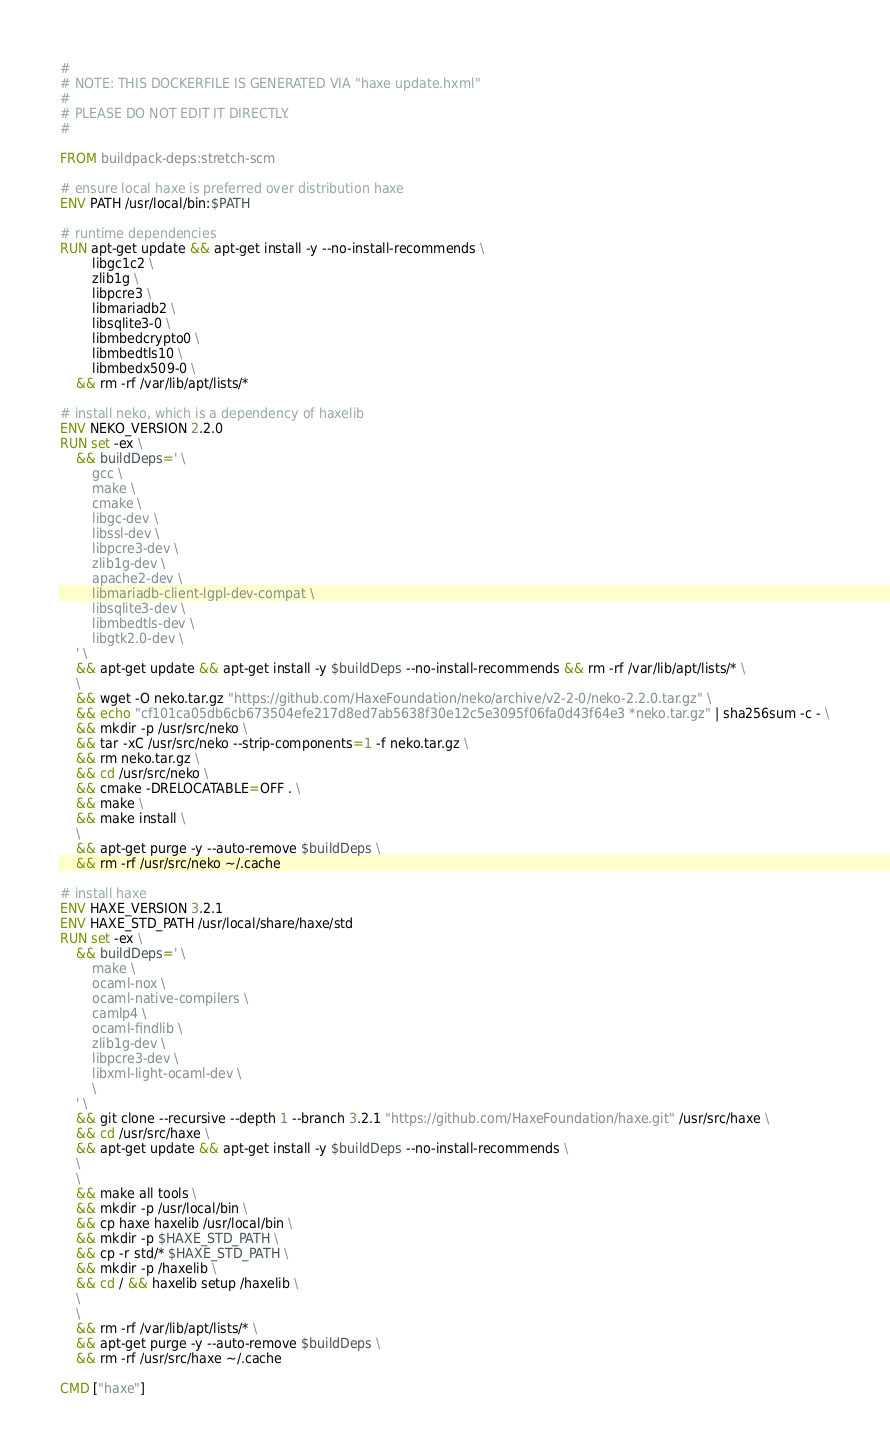Convert code to text. <code><loc_0><loc_0><loc_500><loc_500><_Dockerfile_>#
# NOTE: THIS DOCKERFILE IS GENERATED VIA "haxe update.hxml"
#
# PLEASE DO NOT EDIT IT DIRECTLY.
#

FROM buildpack-deps:stretch-scm

# ensure local haxe is preferred over distribution haxe
ENV PATH /usr/local/bin:$PATH

# runtime dependencies
RUN apt-get update && apt-get install -y --no-install-recommends \
		libgc1c2 \
		zlib1g \
		libpcre3 \
		libmariadb2 \
		libsqlite3-0 \
		libmbedcrypto0 \
		libmbedtls10 \
		libmbedx509-0 \
	&& rm -rf /var/lib/apt/lists/*

# install neko, which is a dependency of haxelib
ENV NEKO_VERSION 2.2.0
RUN set -ex \
	&& buildDeps=' \
		gcc \
		make \
		cmake \
		libgc-dev \
		libssl-dev \
		libpcre3-dev \
		zlib1g-dev \
		apache2-dev \
		libmariadb-client-lgpl-dev-compat \
		libsqlite3-dev \
		libmbedtls-dev \
		libgtk2.0-dev \
	' \
	&& apt-get update && apt-get install -y $buildDeps --no-install-recommends && rm -rf /var/lib/apt/lists/* \
	\
	&& wget -O neko.tar.gz "https://github.com/HaxeFoundation/neko/archive/v2-2-0/neko-2.2.0.tar.gz" \
	&& echo "cf101ca05db6cb673504efe217d8ed7ab5638f30e12c5e3095f06fa0d43f64e3 *neko.tar.gz" | sha256sum -c - \
	&& mkdir -p /usr/src/neko \
	&& tar -xC /usr/src/neko --strip-components=1 -f neko.tar.gz \
	&& rm neko.tar.gz \
	&& cd /usr/src/neko \
	&& cmake -DRELOCATABLE=OFF . \
	&& make \
	&& make install \
	\
	&& apt-get purge -y --auto-remove $buildDeps \
	&& rm -rf /usr/src/neko ~/.cache

# install haxe
ENV HAXE_VERSION 3.2.1
ENV HAXE_STD_PATH /usr/local/share/haxe/std
RUN set -ex \
	&& buildDeps=' \
		make \
		ocaml-nox \
		ocaml-native-compilers \
		camlp4 \
		ocaml-findlib \
		zlib1g-dev \
		libpcre3-dev \
		libxml-light-ocaml-dev \
		\
	' \
	&& git clone --recursive --depth 1 --branch 3.2.1 "https://github.com/HaxeFoundation/haxe.git" /usr/src/haxe \
	&& cd /usr/src/haxe \
	&& apt-get update && apt-get install -y $buildDeps --no-install-recommends \
	\
	\
	&& make all tools \
	&& mkdir -p /usr/local/bin \
	&& cp haxe haxelib /usr/local/bin \
	&& mkdir -p $HAXE_STD_PATH \
	&& cp -r std/* $HAXE_STD_PATH \
	&& mkdir -p /haxelib \
	&& cd / && haxelib setup /haxelib \
	\
	\
	&& rm -rf /var/lib/apt/lists/* \
	&& apt-get purge -y --auto-remove $buildDeps \
	&& rm -rf /usr/src/haxe ~/.cache

CMD ["haxe"]
</code> 